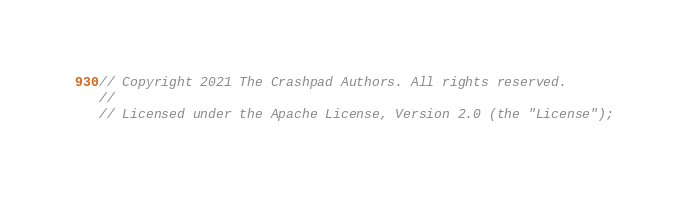Convert code to text. <code><loc_0><loc_0><loc_500><loc_500><_C++_>// Copyright 2021 The Crashpad Authors. All rights reserved.
//
// Licensed under the Apache License, Version 2.0 (the "License");</code> 